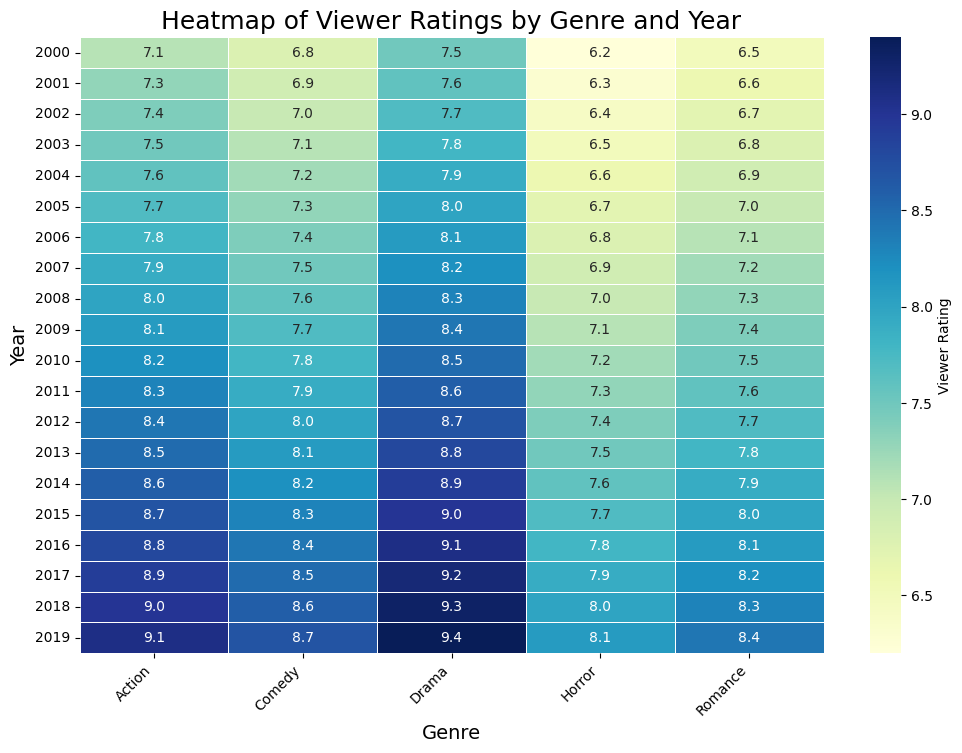What year had the highest viewer rating for the Action genre? To find the highest viewer rating for the Action genre, look for the deepest colored (most saturated) cell in the "Action" column. The value is 9.1 in 2019.
Answer: 2019 Which genre had the lowest viewer rating in 2000? Scan the row corresponding to 2000 and identify the cell with the least saturated color, which is "Horror" with a rating of 6.2.
Answer: Horror What is the average viewer rating for Drama from 2000 to 2005? Add the viewer ratings for Drama from 2000 to 2005: (7.5 + 7.6 + 7.7 + 7.8 + 7.9 + 8.0) = 47.5. Then divide by the number of years, 47.5 / 6 = 7.92
Answer: 7.92 Which genre showed the most consistent (least variation) viewer ratings over the years? By visually inspecting the heatmap, the Comedy genre shows the least variation in color intensity over the years, indicating consistent viewer ratings.
Answer: Comedy In what year did the Romance genre first surpass a viewer rating of 7.0? Scan the Romance column from top to bottom and find the first instance where the value exceeds 7.0, which happens in 2006 with a rating of 7.1.
Answer: 2006 What's the difference in viewer rating between the highest-rated and lowest-rated genres in 2015? In 2015, identify the highest (Drama, 9.0) and the lowest (Horror, 7.7) ratings. The difference is 9.0 - 7.7 = 1.3
Answer: 1.3 Which genre saw the largest increase in viewer ratings from 2010 to 2015? Calculate the difference for each genre between 2010 and 2015, and identify the largest change. Action: 8.7 − 8.2 = 0.5, Drama: 9.0 − 8.5 = 0.5, Comedy: 8.3 − 7.8 = 0.5, Romance: 8.0 − 7.5 = 0.5, Horror: 7.7 − 7.2 = 0.5. All genres saw the same increase, 0.5
Answer: All genres equal increase of 0.5 How do the viewer ratings for Comedy in 2005 and 2010 compare? Look at the values for Comedy in 2005 (7.3) and 2010 (7.8), and compare them. 2010 has a higher viewer rating.
Answer: 2010 Which year had the highest average viewer rating across all genres? Calculate the average viewer rating for each year and determine the highest. For 2019, sum all genres ratings: 9.1 (Action) + 9.4 (Drama) + 8.7 (Comedy) + 8.4 (Romance) + 8.1 (Horror) = 43.70. Divide by 5 genres: 43.70/5 = 8.74. 2019 has the highest average.
Answer: 2019 